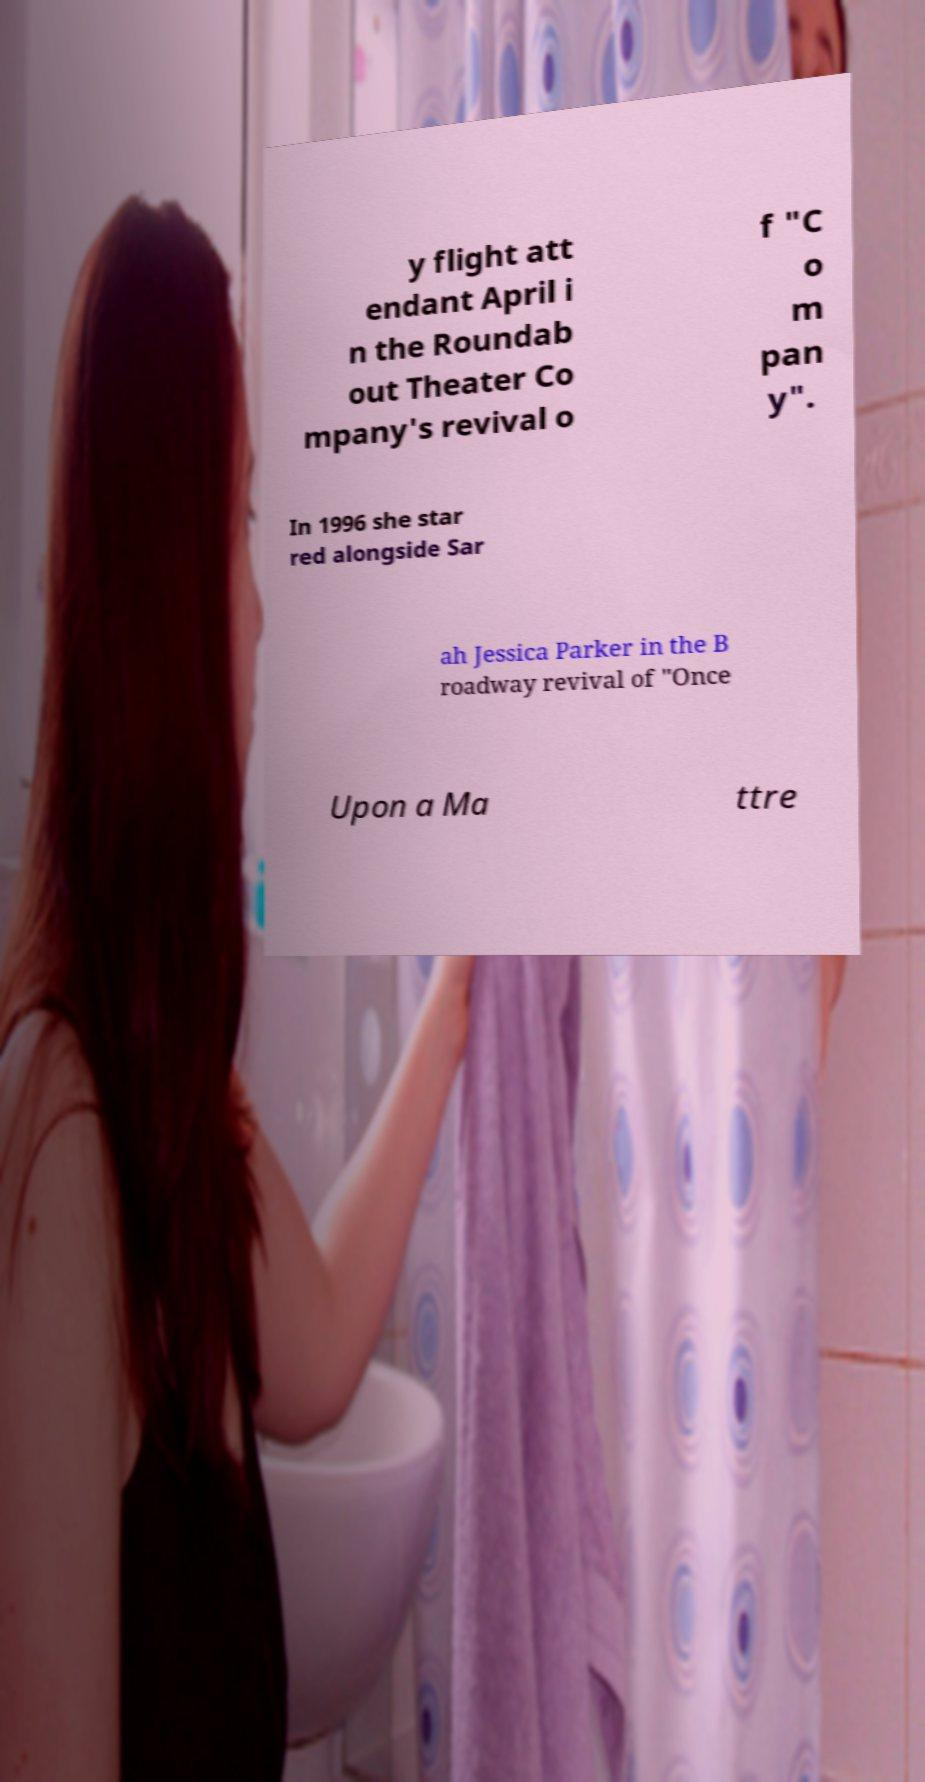Can you read and provide the text displayed in the image?This photo seems to have some interesting text. Can you extract and type it out for me? y flight att endant April i n the Roundab out Theater Co mpany's revival o f "C o m pan y". In 1996 she star red alongside Sar ah Jessica Parker in the B roadway revival of "Once Upon a Ma ttre 